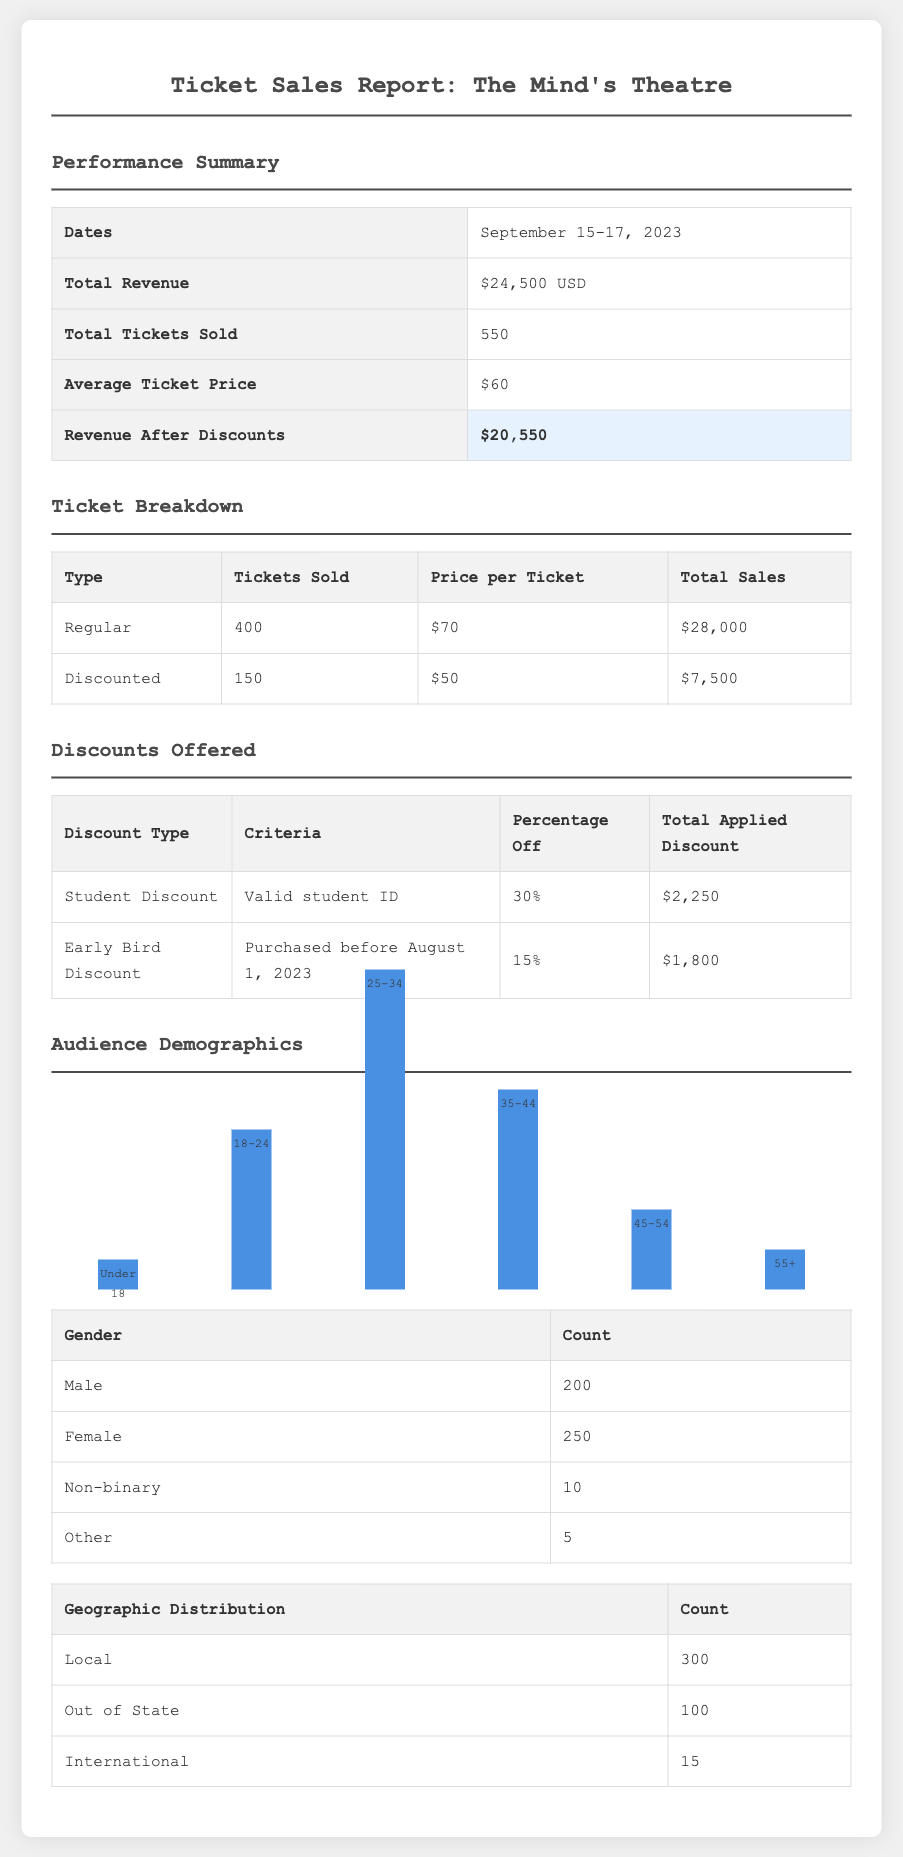what is the total revenue? The total revenue is listed in the report as $24,500 USD.
Answer: $24,500 USD how many total tickets were sold? The total number of tickets sold is provided in the document.
Answer: 550 what was the average ticket price? The average ticket price is calculated and mentioned in the report.
Answer: $60 what is the revenue after discounts? The report specifies the revenue after applying discounts as $20,550.
Answer: $20,550 how many discounted tickets were sold? The number of discounted tickets sold can be found in the ticket breakdown section.
Answer: 150 what discount percentage was offered to students? The student discount percentage is explicitly stated in the discounts table.
Answer: 30% what demographic group had the highest attendance? The audience demographic chart shows the 25-34 age group had the highest attendance.
Answer: 25-34 how many male attendees were there? The document provides a specific count of male attendees in the demographics section.
Answer: 200 what was the total applied discount for the Early Bird Discount? The total applied discount for the Early Bird Discount can be found in the discounts table.
Answer: $1,800 